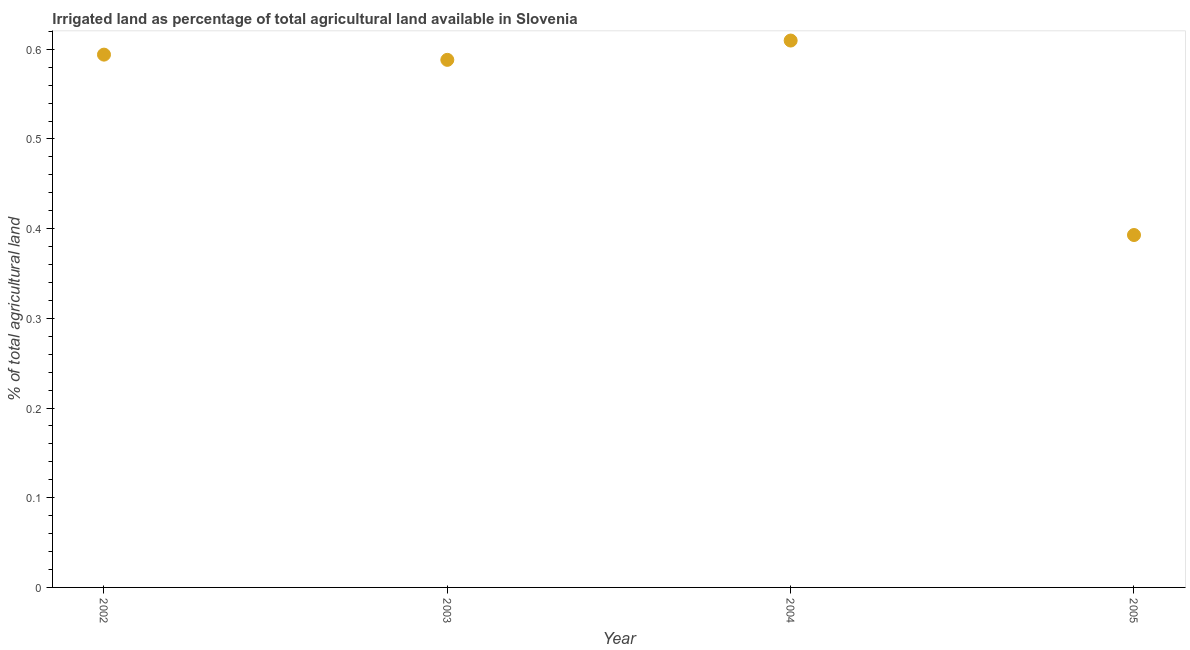What is the percentage of agricultural irrigated land in 2002?
Offer a terse response. 0.59. Across all years, what is the maximum percentage of agricultural irrigated land?
Provide a short and direct response. 0.61. Across all years, what is the minimum percentage of agricultural irrigated land?
Give a very brief answer. 0.39. In which year was the percentage of agricultural irrigated land minimum?
Provide a succinct answer. 2005. What is the sum of the percentage of agricultural irrigated land?
Provide a short and direct response. 2.18. What is the difference between the percentage of agricultural irrigated land in 2002 and 2004?
Offer a terse response. -0.02. What is the average percentage of agricultural irrigated land per year?
Provide a short and direct response. 0.55. What is the median percentage of agricultural irrigated land?
Give a very brief answer. 0.59. In how many years, is the percentage of agricultural irrigated land greater than 0.02 %?
Your answer should be compact. 4. What is the ratio of the percentage of agricultural irrigated land in 2002 to that in 2004?
Keep it short and to the point. 0.97. Is the difference between the percentage of agricultural irrigated land in 2002 and 2003 greater than the difference between any two years?
Your answer should be very brief. No. What is the difference between the highest and the second highest percentage of agricultural irrigated land?
Your answer should be compact. 0.02. Is the sum of the percentage of agricultural irrigated land in 2002 and 2004 greater than the maximum percentage of agricultural irrigated land across all years?
Offer a terse response. Yes. What is the difference between the highest and the lowest percentage of agricultural irrigated land?
Make the answer very short. 0.22. In how many years, is the percentage of agricultural irrigated land greater than the average percentage of agricultural irrigated land taken over all years?
Make the answer very short. 3. Does the percentage of agricultural irrigated land monotonically increase over the years?
Give a very brief answer. No. How many dotlines are there?
Keep it short and to the point. 1. How many years are there in the graph?
Offer a very short reply. 4. What is the difference between two consecutive major ticks on the Y-axis?
Your answer should be compact. 0.1. Are the values on the major ticks of Y-axis written in scientific E-notation?
Offer a terse response. No. Does the graph contain grids?
Ensure brevity in your answer.  No. What is the title of the graph?
Provide a short and direct response. Irrigated land as percentage of total agricultural land available in Slovenia. What is the label or title of the Y-axis?
Provide a succinct answer. % of total agricultural land. What is the % of total agricultural land in 2002?
Give a very brief answer. 0.59. What is the % of total agricultural land in 2003?
Provide a succinct answer. 0.59. What is the % of total agricultural land in 2004?
Provide a short and direct response. 0.61. What is the % of total agricultural land in 2005?
Provide a succinct answer. 0.39. What is the difference between the % of total agricultural land in 2002 and 2003?
Provide a short and direct response. 0.01. What is the difference between the % of total agricultural land in 2002 and 2004?
Your answer should be very brief. -0.02. What is the difference between the % of total agricultural land in 2002 and 2005?
Your answer should be very brief. 0.2. What is the difference between the % of total agricultural land in 2003 and 2004?
Provide a succinct answer. -0.02. What is the difference between the % of total agricultural land in 2003 and 2005?
Provide a short and direct response. 0.2. What is the difference between the % of total agricultural land in 2004 and 2005?
Your answer should be compact. 0.22. What is the ratio of the % of total agricultural land in 2002 to that in 2003?
Your response must be concise. 1.01. What is the ratio of the % of total agricultural land in 2002 to that in 2005?
Offer a terse response. 1.51. What is the ratio of the % of total agricultural land in 2003 to that in 2005?
Your response must be concise. 1.5. What is the ratio of the % of total agricultural land in 2004 to that in 2005?
Offer a terse response. 1.55. 